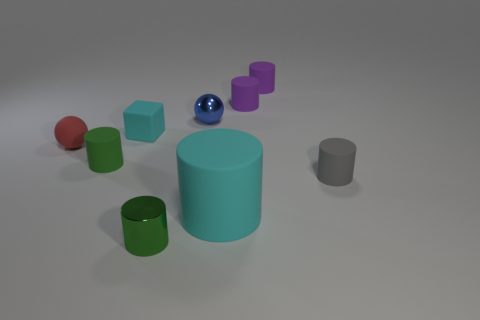There is a tiny block that is the same color as the big object; what is it made of?
Your answer should be compact. Rubber. Is there any other thing that has the same shape as the small cyan object?
Your answer should be compact. No. There is a cyan rubber thing right of the small cylinder in front of the small gray matte object; what size is it?
Provide a short and direct response. Large. How many small objects are red things or cyan cylinders?
Your response must be concise. 1. Are there fewer small gray cylinders than brown objects?
Your response must be concise. No. Is there anything else that has the same size as the cyan matte cylinder?
Offer a very short reply. No. Is the block the same color as the big cylinder?
Make the answer very short. Yes. Are there more green matte spheres than tiny rubber cubes?
Your answer should be compact. No. How many other things are there of the same color as the large thing?
Your response must be concise. 1. There is a small object in front of the gray rubber cylinder; how many cyan matte things are to the right of it?
Your response must be concise. 1. 